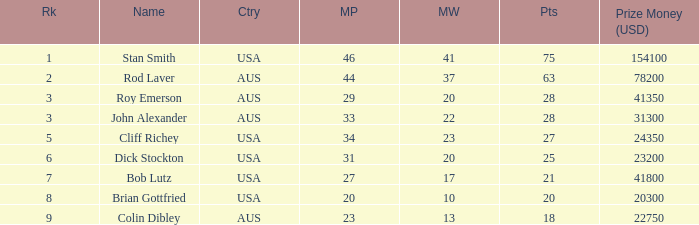How many countries had 21 points 1.0. 